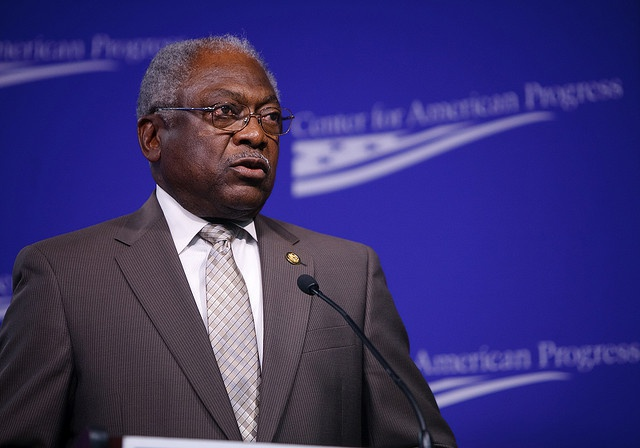Describe the objects in this image and their specific colors. I can see people in navy, black, gray, and maroon tones and tie in navy, lightgray, darkgray, and gray tones in this image. 